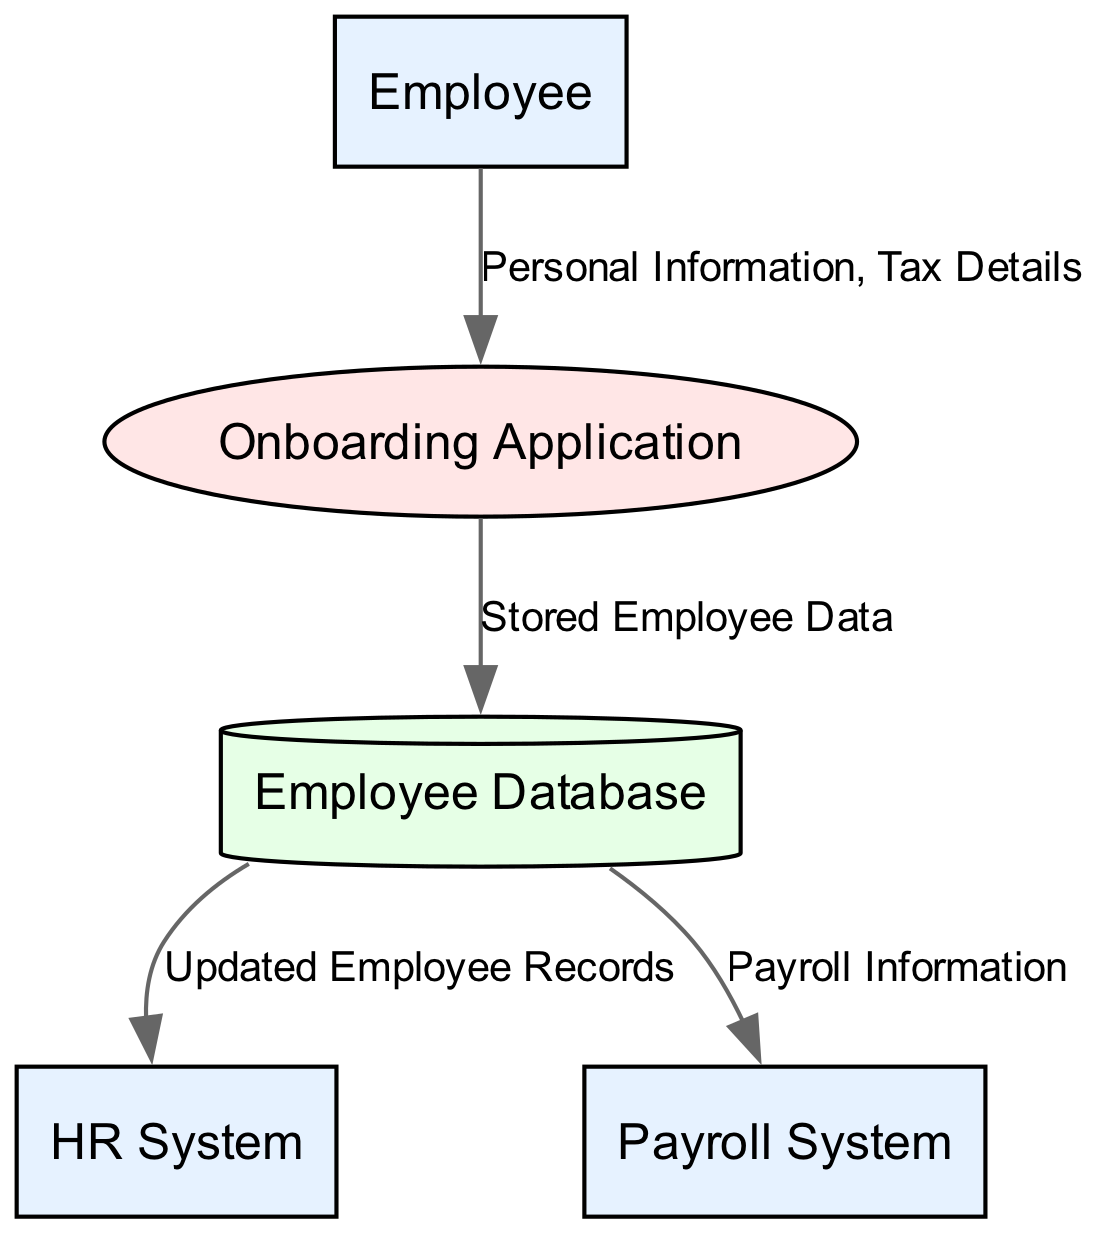What are the external entities in this diagram? The diagram features five entities, and among them, the external entities are specified as the HR System, Payroll System, and Employee.
Answer: HR System, Payroll System, Employee How many processes are illustrated in the diagram? The diagram outlines four distinct processes: Collect Employee Information, Store Employee Data, Send Payroll Information, and Update HR Records.
Answer: 4 What is the output of the "Collect Employee Information" process? The input to this process comes from the Employee entity, and it outputs the collected information to the Onboarding Application.
Answer: Onboarding Application What information does the Employee provide to the Onboarding Application? According to the data flow, the Employee sends Personal Information and Tax Details to the Onboarding Application.
Answer: Personal Information, Tax Details Which process receives data from the Employee Database? The Employee Database provides data to two processes: Send Payroll Information and Update HR Records.
Answer: Send Payroll Information, Update HR Records What type of data store is used in the diagram? The diagram specifies a Data Store, which is represented as the Employee Database, indicating it serves as storage for the employee records.
Answer: Employee Database Which entity receives updated records from the Employee Database? The Employee Database is linked to the HR System, indicating that the HR System receives updated employee records from it.
Answer: HR System How many data flows are present in the diagram? The diagram consists of four data flows, which detail transfers of information between various entities and processes.
Answer: 4 What type of information does the Payroll System receive? The Payroll System receives Payroll Information, which is transmitted from the Employee Database as part of the data flow.
Answer: Payroll Information 